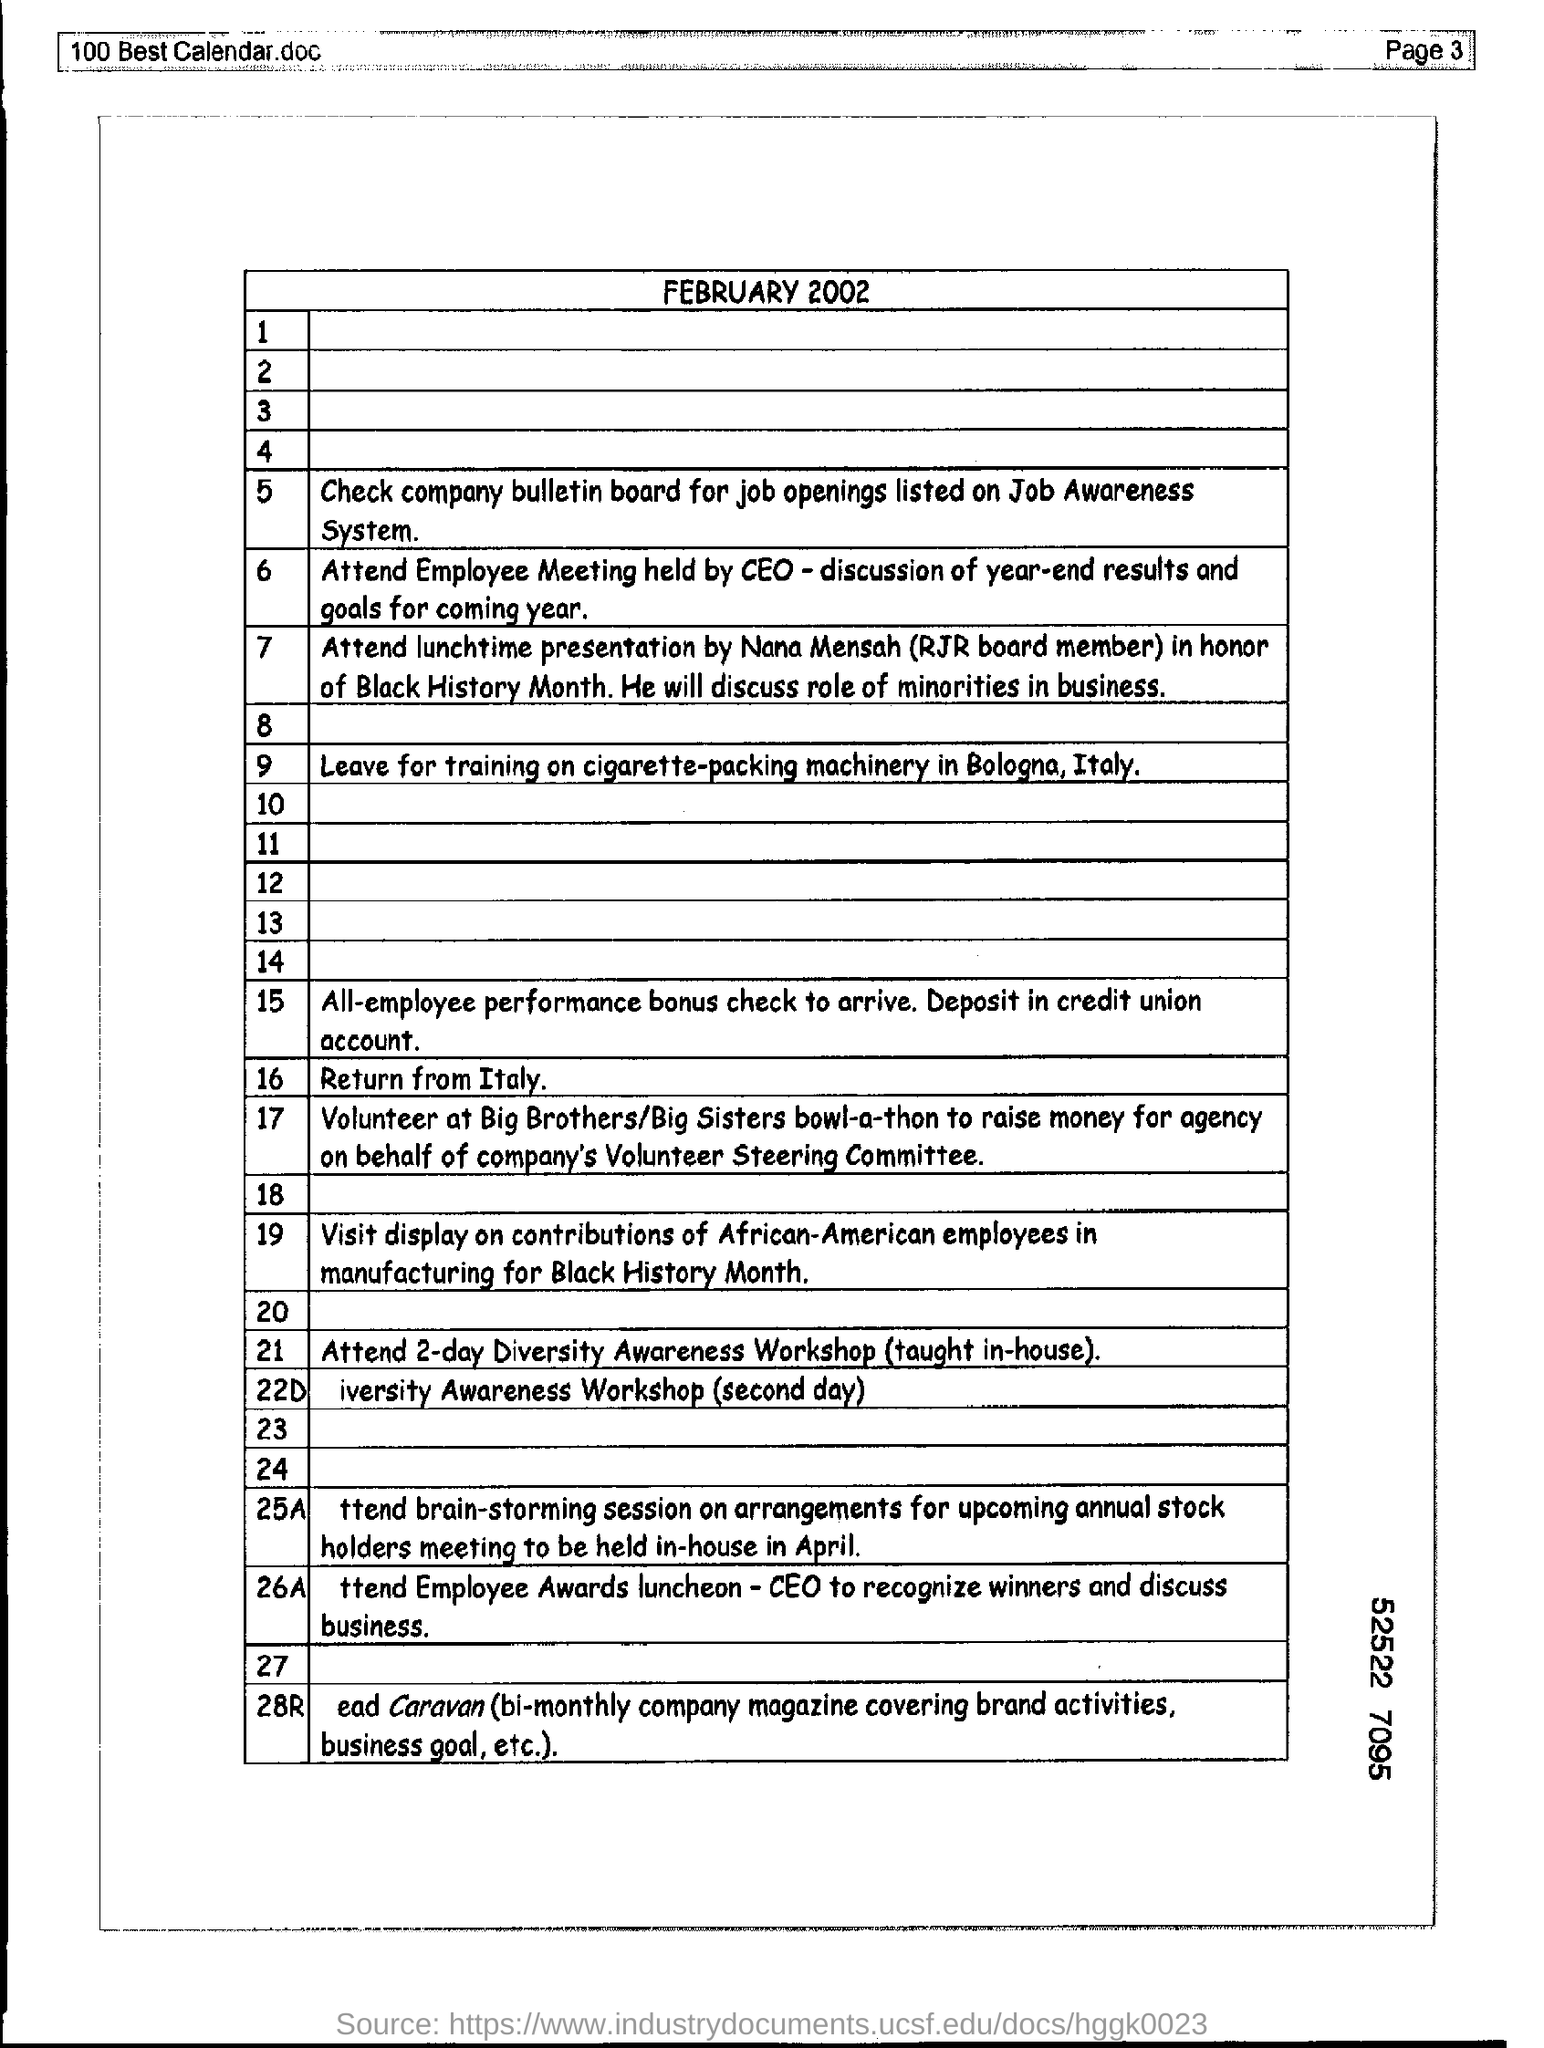Mention the page number at top right corner of the page ?
Provide a succinct answer. Page 3. 